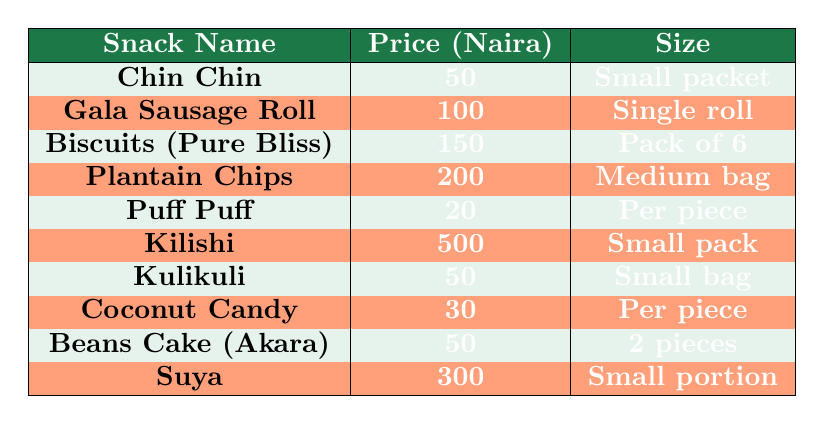What is the price of Puff Puff? From the table, Puff Puff is listed with a price of 20 Naira.
Answer: 20 Naira Which snack is the most expensive? The table shows Kilishi with a price of 500 Naira, which is higher than any other snack's price.
Answer: Kilishi How much do Coconut Candy and Puff Puff cost together? The price of Coconut Candy is 30 Naira and Puff Puff is 20 Naira. Adding these together (30 + 20) gives a total of 50 Naira.
Answer: 50 Naira Is the price of Biscuits greater than the price of Gala Sausage Roll? Biscuits costs 150 Naira and Gala Sausage Roll costs 100 Naira, so yes, 150 is greater than 100.
Answer: Yes What is the average price of the snacks in the table? First, sum all snack prices: 50 + 100 + 150 + 200 + 20 + 500 + 50 + 30 + 50 + 300 = 1,450 Naira. Then, divide by the number of snacks (10): 1,450 / 10 = 145.
Answer: 145 Naira How many snacks cost exactly 50 Naira? The table lists three snacks priced at 50 Naira: Chin Chin, Kulikuli, and Beans Cake (Akara). Therefore, there are 3 snacks.
Answer: 3 snacks If you buy one of each snack, how much will it cost in total? The total cost is found by adding all the snack prices together: 50 + 100 + 150 + 200 + 20 + 500 + 50 + 30 + 50 + 300 = 1,450 Naira.
Answer: 1,450 Naira Does a single Coconut Candy cost less than a single Pieces of Puff Puff? Coconut Candy costs 30 Naira and a single Puff Puff costs 20 Naira, so 30 is greater than 20.
Answer: No 